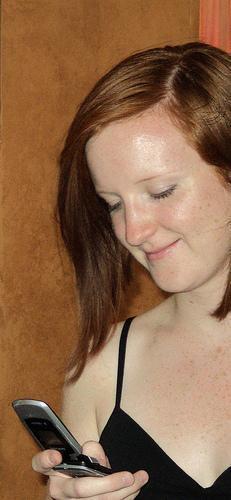How many phones are in the picture?
Give a very brief answer. 1. How many eyes does the woman have?
Give a very brief answer. 2. 